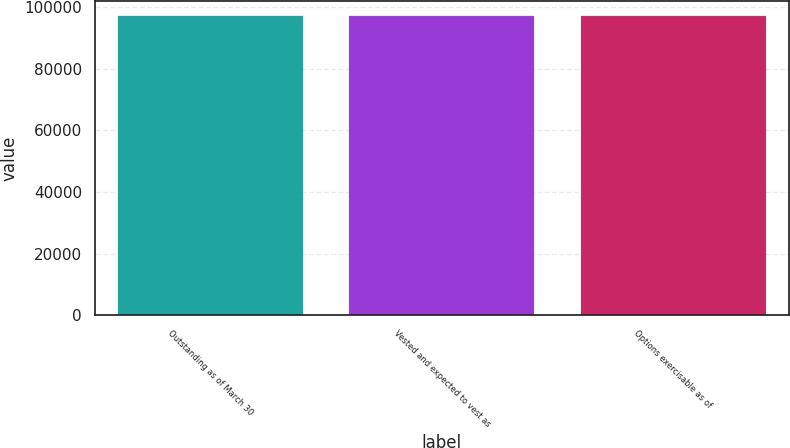Convert chart. <chart><loc_0><loc_0><loc_500><loc_500><bar_chart><fcel>Outstanding as of March 30<fcel>Vested and expected to vest as<fcel>Options exercisable as of<nl><fcel>96925<fcel>96925.1<fcel>96925.2<nl></chart> 